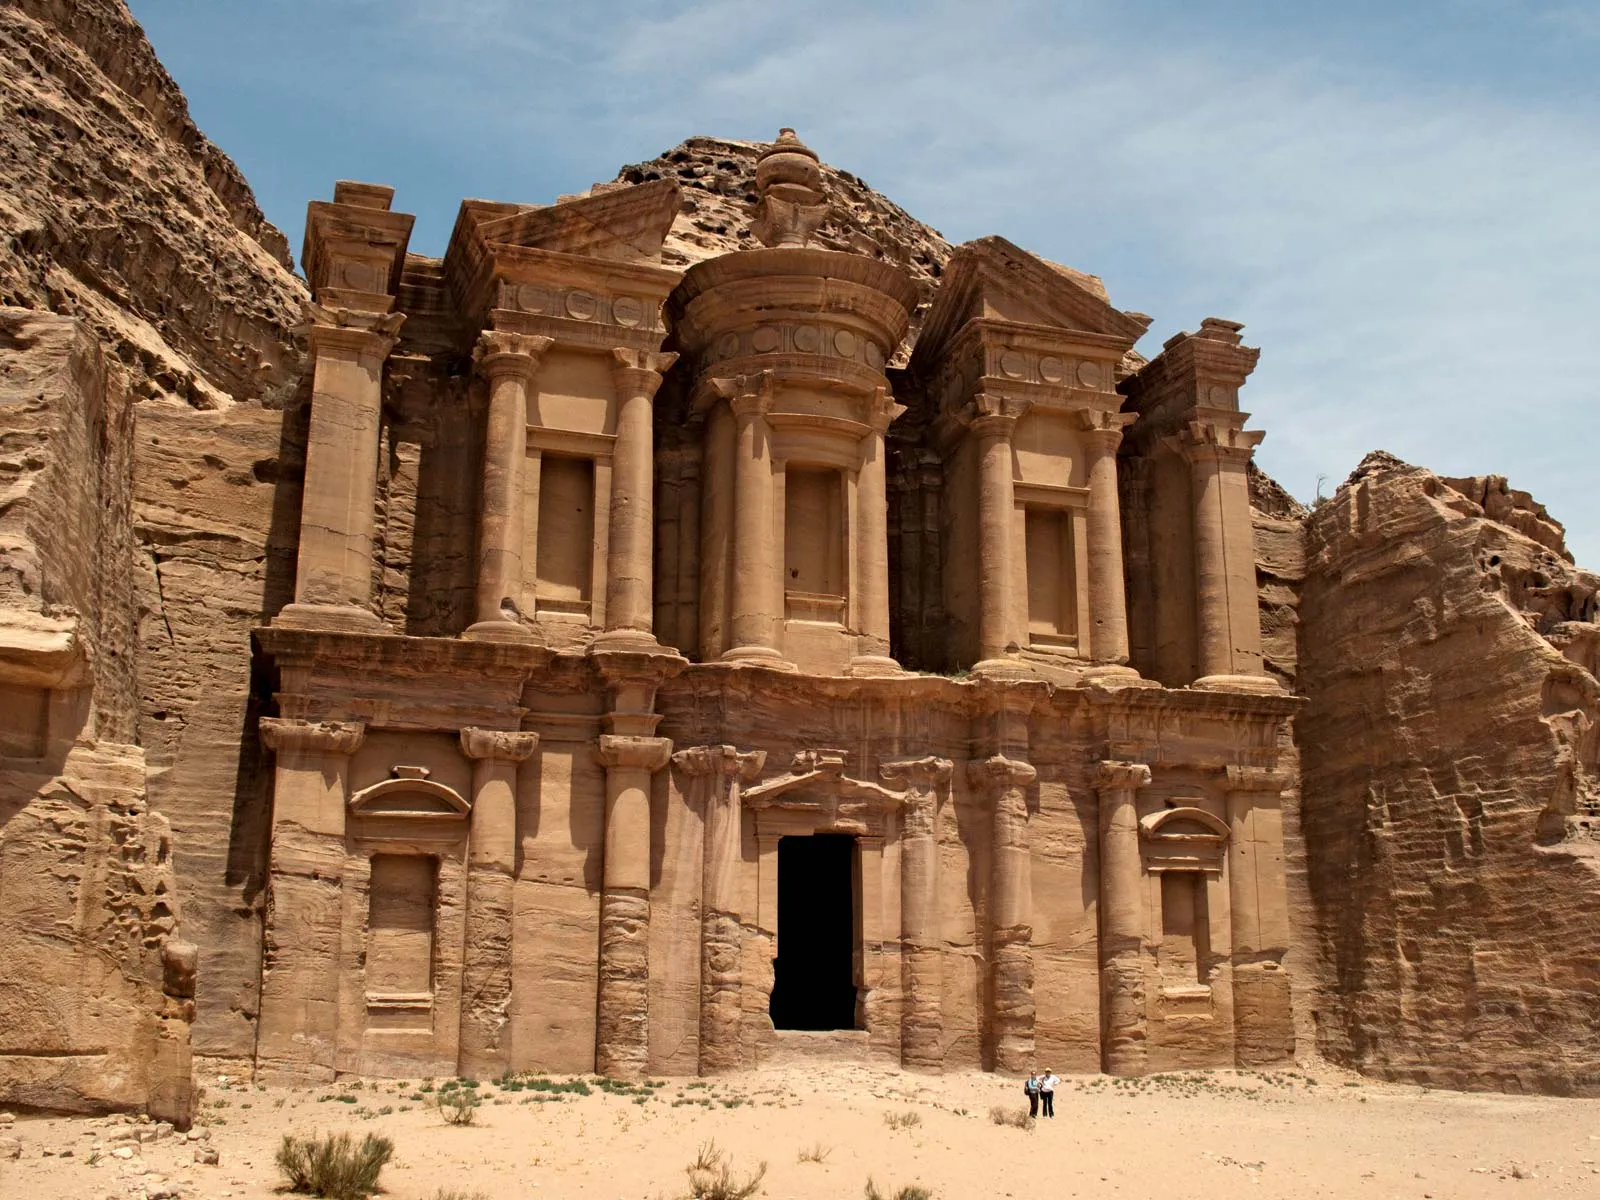Can you tell me more about the historical significance of this structure? The Monastery, or Ad Deir, is one of the most iconic monuments in Petra, Jordan. It dates back to the 1st century AD and was likely used as a religious site. The Nabateans, who were skilled in water conservation and stone carving, built this majestic structure. They carved it directly into the cliff, creating a facade that stands 45 meters high. The Monastery's grand scale and intricate details reflect the prosperity and architectural ingenuity of the Nabatean civilization. Over the centuries, it has served various purposes, including a site for Christian worship during the Byzantine period. Its significance extends beyond its architectural beauty; it is a testament to the cultural and historical richness of the ancient Nabateans and their impact on the region. What other famous structures exist in Petra? Apart from the Monastery, Petra is home to several other famous structures that highlight its historical and architectural importance. The most renowned is the Treasury (Al-Khazneh), which greets visitors with its stunning rock-cut facade. Other notable structures include the Street of Facades, lined with numerous tombs and houses; the Royal Tombs, which showcase elaborate rock-cut architecture; the Amphitheater, which could seat thousands of spectators; and the Great Temple, indicative of Petra’s religious and cultural significance. These monuments, together with the intricate system of water channels and cisterns, reflect the ingenuity and the high level of civilization achieved by the Nabateans. 